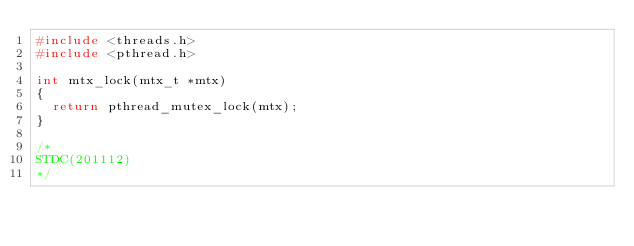<code> <loc_0><loc_0><loc_500><loc_500><_C_>#include <threads.h>
#include <pthread.h>

int mtx_lock(mtx_t *mtx)
{
	return pthread_mutex_lock(mtx);
}

/*
STDC(201112)
*/
</code> 